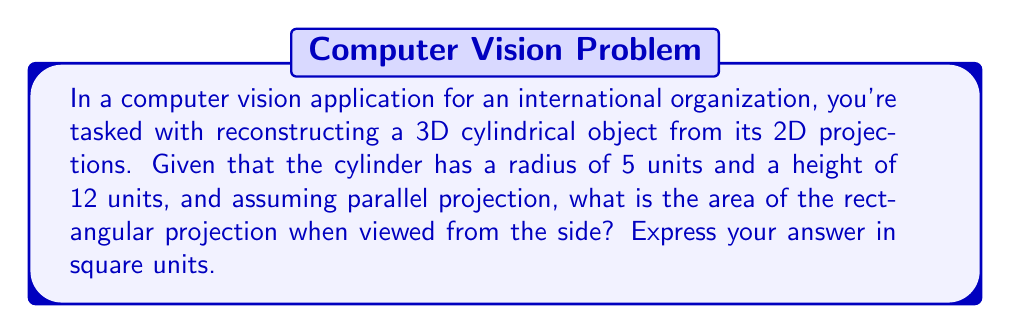Help me with this question. To solve this problem, we need to follow these steps:

1) First, let's understand what we're looking at:
   - We have a cylinder with radius $r = 5$ units and height $h = 12$ units.
   - We're viewing it from the side under parallel projection.

2) In a parallel projection from the side view, a cylinder appears as a rectangle.

3) The dimensions of this rectangle are:
   - Width: Equal to the diameter of the cylinder base, which is twice the radius.
   - Height: Equal to the height of the cylinder.

4) Let's calculate the width of the rectangle:
   $$ \text{Width} = 2r = 2 * 5 = 10 \text{ units} $$

5) The height of the rectangle is already given as 12 units.

6) Now, we can calculate the area of the rectangle:
   $$ \text{Area} = \text{Width} * \text{Height} $$
   $$ \text{Area} = 10 * 12 = 120 \text{ square units} $$

Therefore, the area of the rectangular projection is 120 square units.
Answer: 120 square units 